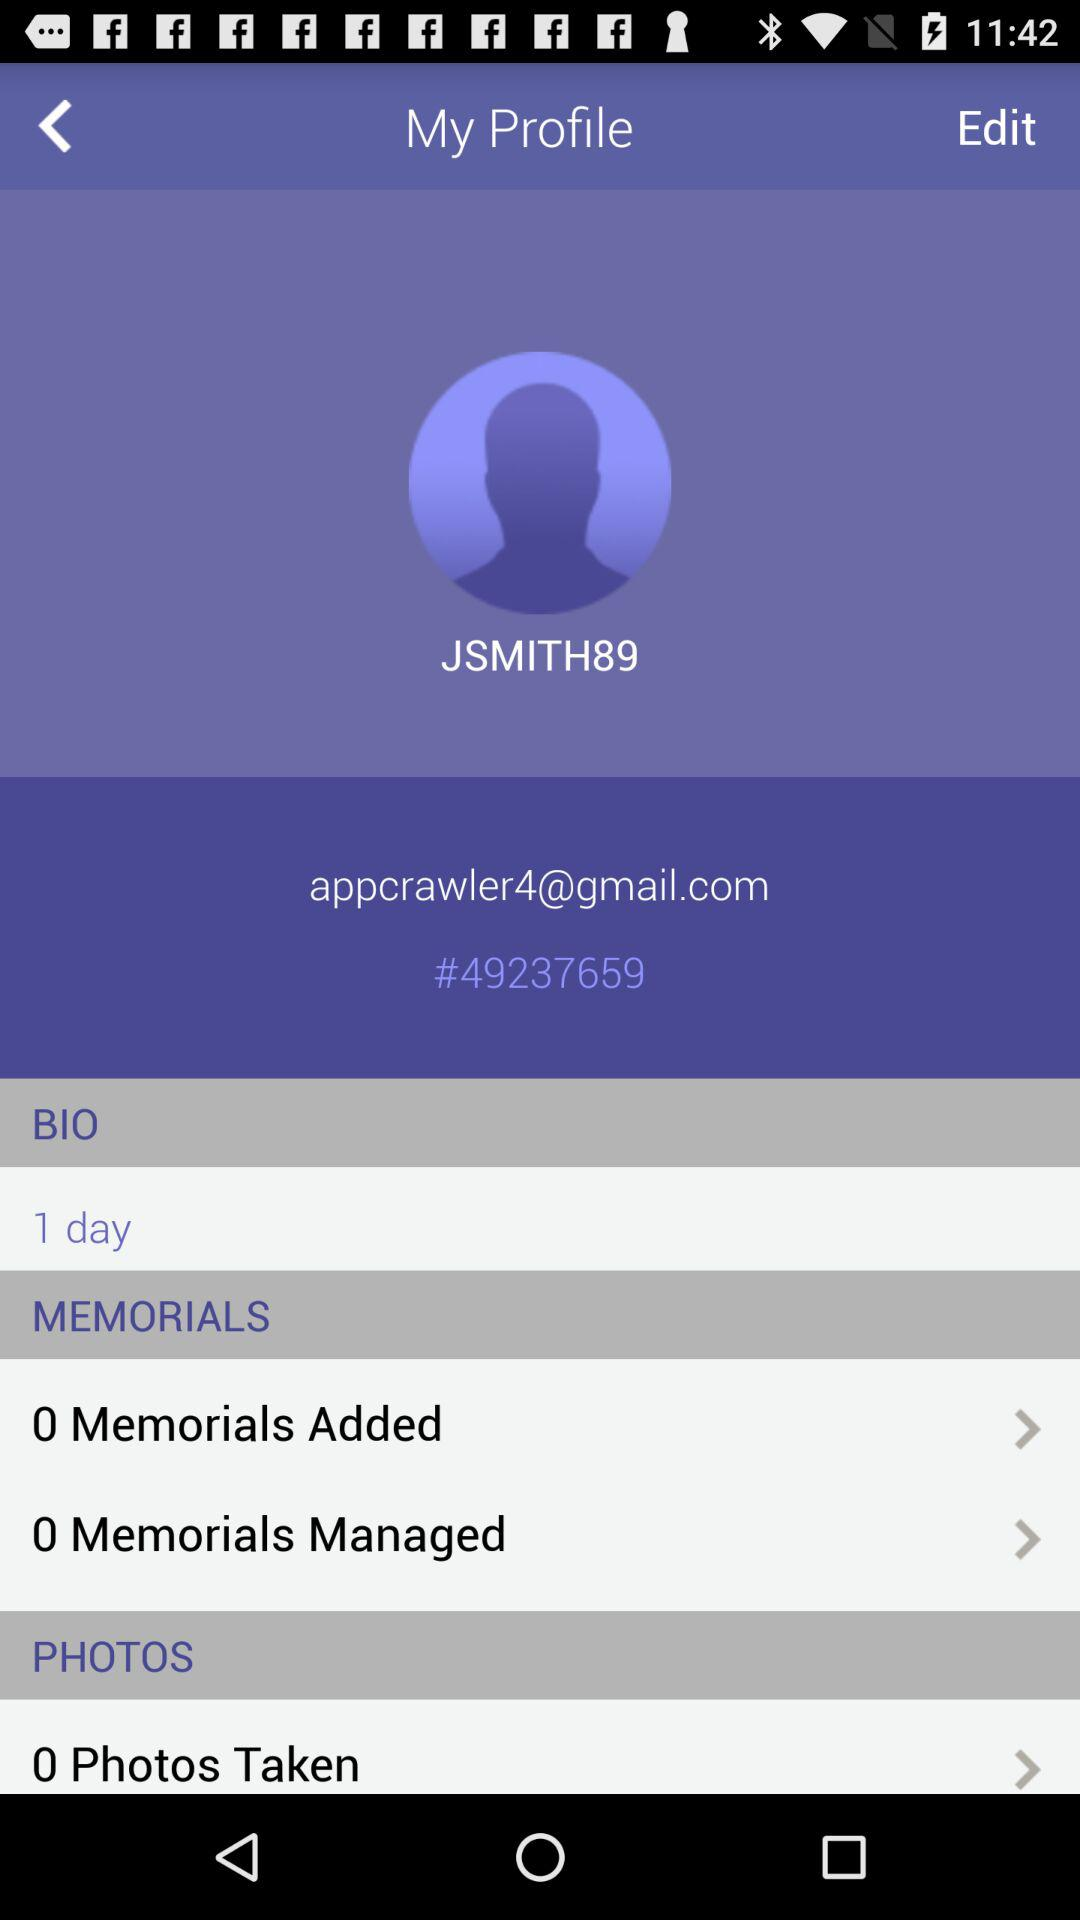What is the shown ID? The shown ID is #49237659. 